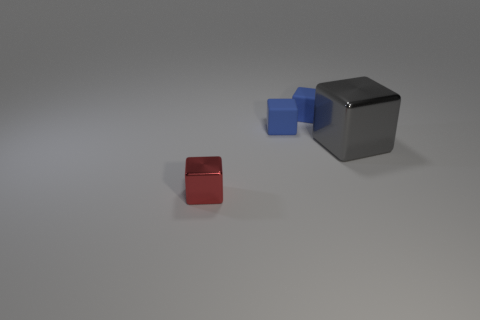Is the big shiny thing the same shape as the red thing?
Ensure brevity in your answer.  Yes. How many metallic cubes are to the right of the small red metal object and on the left side of the big thing?
Keep it short and to the point. 0. Is there any other thing that is the same shape as the red object?
Ensure brevity in your answer.  Yes. Is the color of the big thing the same as the cube that is in front of the big gray metal block?
Your response must be concise. No. What number of other objects are the same material as the gray cube?
Your response must be concise. 1. What is the material of the gray block?
Provide a short and direct response. Metal. How many big objects are red objects or brown rubber spheres?
Make the answer very short. 0. How many tiny blue cubes are left of the tiny red metal cube?
Your answer should be compact. 0. Are there any tiny cubes that have the same color as the big metallic object?
Provide a short and direct response. No. What number of blue things are either large metal cubes or metal objects?
Offer a terse response. 0. 